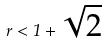<formula> <loc_0><loc_0><loc_500><loc_500>r < 1 + \sqrt { 2 }</formula> 